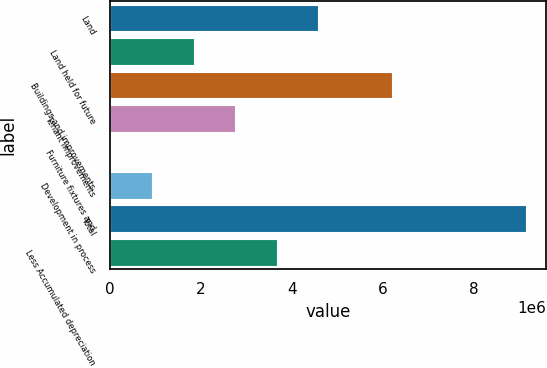Convert chart. <chart><loc_0><loc_0><loc_500><loc_500><bar_chart><fcel>Land<fcel>Land held for future<fcel>Buildings and improvements<fcel>Tenant improvements<fcel>Furniture fixtures and<fcel>Development in process<fcel>Total<fcel>Less Accumulated depreciation<nl><fcel>4.58777e+06<fcel>1.84973e+06<fcel>6.21475e+06<fcel>2.76241e+06<fcel>24363<fcel>937044<fcel>9.15118e+06<fcel>3.67509e+06<nl></chart> 